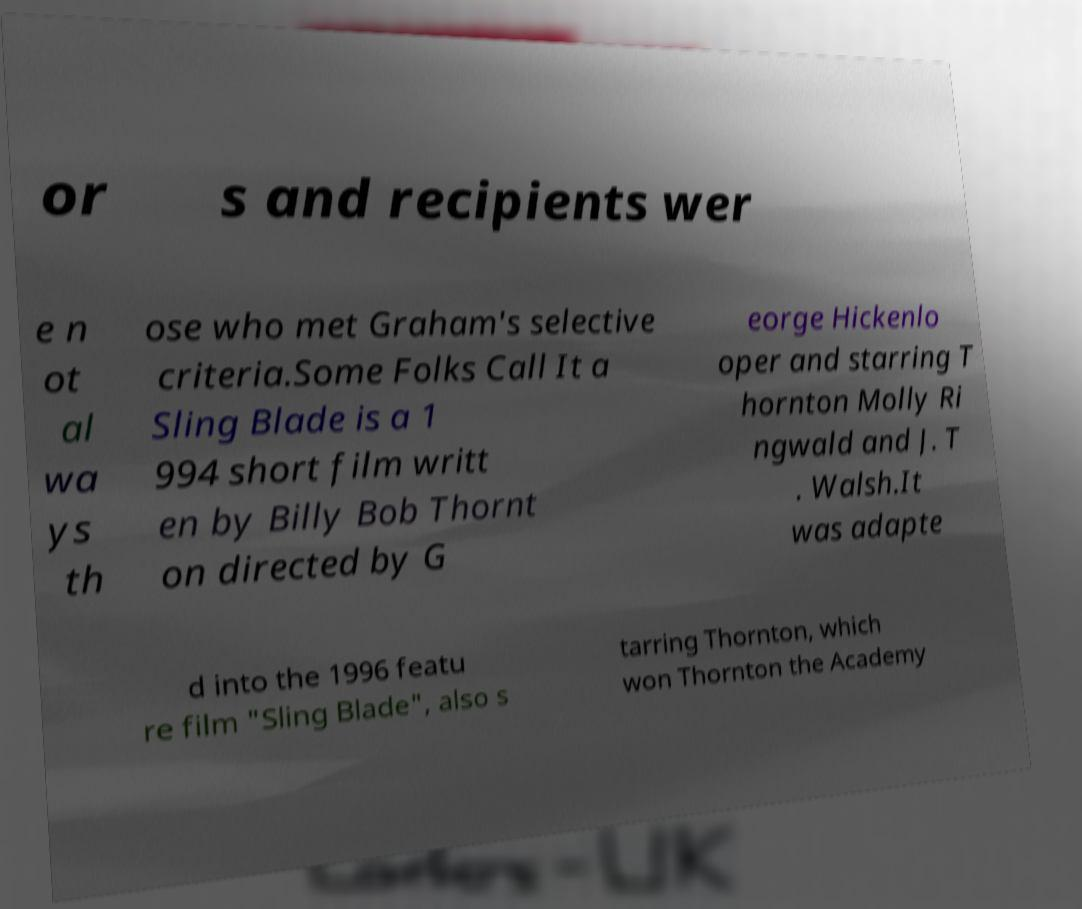Can you accurately transcribe the text from the provided image for me? or s and recipients wer e n ot al wa ys th ose who met Graham's selective criteria.Some Folks Call It a Sling Blade is a 1 994 short film writt en by Billy Bob Thornt on directed by G eorge Hickenlo oper and starring T hornton Molly Ri ngwald and J. T . Walsh.It was adapte d into the 1996 featu re film "Sling Blade", also s tarring Thornton, which won Thornton the Academy 